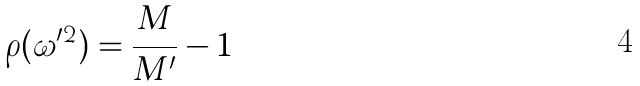Convert formula to latex. <formula><loc_0><loc_0><loc_500><loc_500>\rho ( \omega ^ { \prime 2 } ) = \frac { M } { M ^ { \prime } } - 1</formula> 